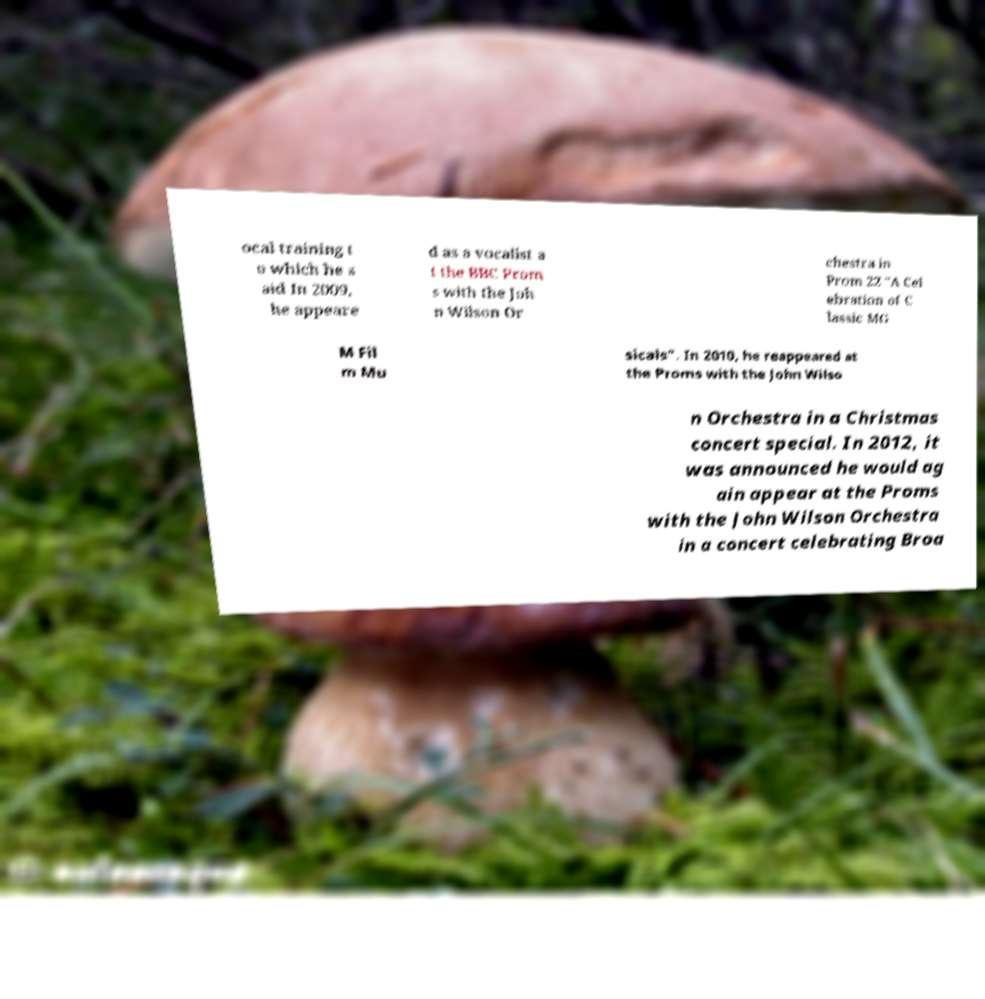What messages or text are displayed in this image? I need them in a readable, typed format. ocal training t o which he s aid In 2009, he appeare d as a vocalist a t the BBC Prom s with the Joh n Wilson Or chestra in Prom 22 "A Cel ebration of C lassic MG M Fil m Mu sicals". In 2010, he reappeared at the Proms with the John Wilso n Orchestra in a Christmas concert special. In 2012, it was announced he would ag ain appear at the Proms with the John Wilson Orchestra in a concert celebrating Broa 